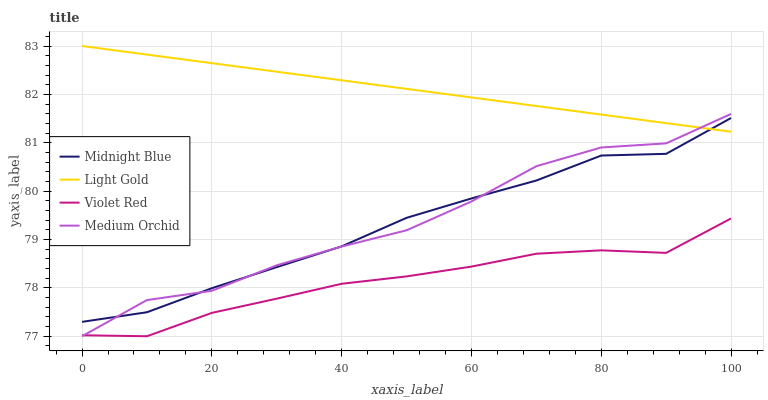Does Violet Red have the minimum area under the curve?
Answer yes or no. Yes. Does Light Gold have the maximum area under the curve?
Answer yes or no. Yes. Does Medium Orchid have the minimum area under the curve?
Answer yes or no. No. Does Medium Orchid have the maximum area under the curve?
Answer yes or no. No. Is Light Gold the smoothest?
Answer yes or no. Yes. Is Medium Orchid the roughest?
Answer yes or no. Yes. Is Medium Orchid the smoothest?
Answer yes or no. No. Is Light Gold the roughest?
Answer yes or no. No. Does Violet Red have the lowest value?
Answer yes or no. Yes. Does Light Gold have the lowest value?
Answer yes or no. No. Does Light Gold have the highest value?
Answer yes or no. Yes. Does Medium Orchid have the highest value?
Answer yes or no. No. Is Violet Red less than Light Gold?
Answer yes or no. Yes. Is Midnight Blue greater than Violet Red?
Answer yes or no. Yes. Does Midnight Blue intersect Medium Orchid?
Answer yes or no. Yes. Is Midnight Blue less than Medium Orchid?
Answer yes or no. No. Is Midnight Blue greater than Medium Orchid?
Answer yes or no. No. Does Violet Red intersect Light Gold?
Answer yes or no. No. 